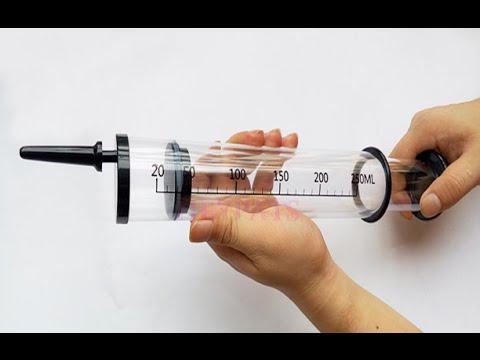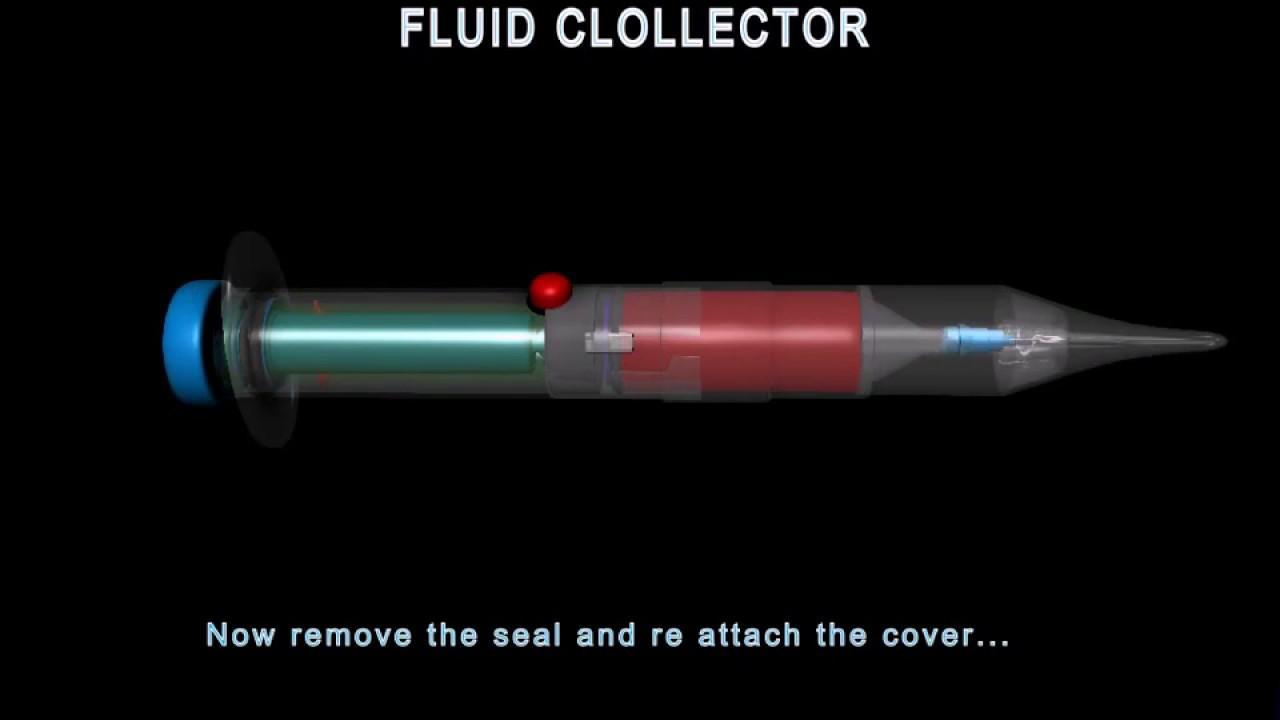The first image is the image on the left, the second image is the image on the right. Considering the images on both sides, is "The left image shows a clear cylinder with colored plastic on each end, and the right image shows something with a rightward-facing point" valid? Answer yes or no. Yes. The first image is the image on the left, the second image is the image on the right. Given the left and right images, does the statement "One syringe needle is covered." hold true? Answer yes or no. Yes. 